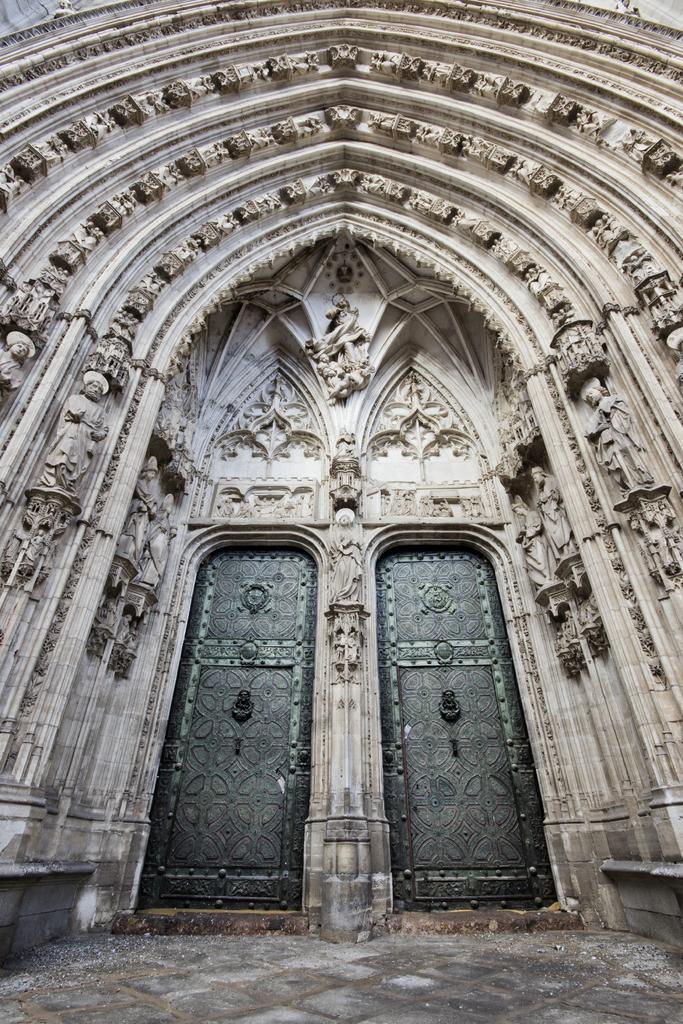In one or two sentences, can you explain what this image depicts? This is an ancient building and doors. There are statues and designs on the wall. At the bottom we can see ground. 